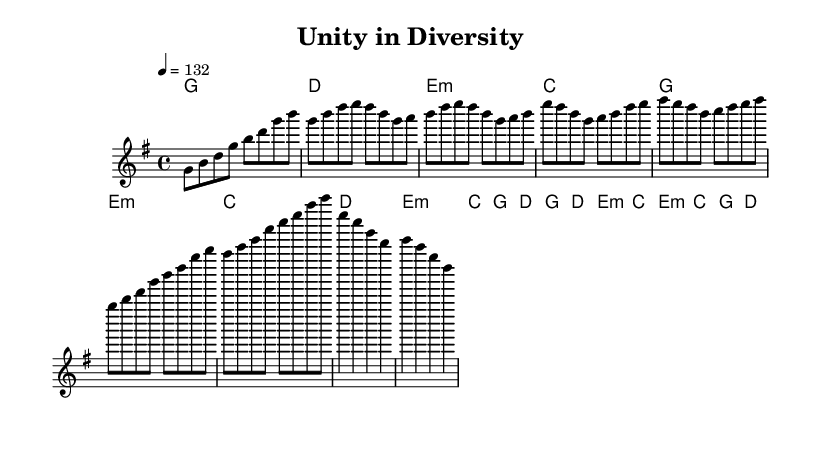What is the key signature of this music? The key signature is G major, which has one sharp (F#).
Answer: G major What is the time signature of this music? The time signature is 4/4, indicating four beats per measure.
Answer: 4/4 What is the tempo marking of this piece? The tempo marking is 132 beats per minute, as indicated by "4 = 132."
Answer: 132 How many measures are in the bridge section? The bridge section consists of two measures, as seen in the number of bars in that segment.
Answer: 2 What is the chord progression of the pre-chorus? The chord progression in the pre-chorus is E minor, C, G, D, based on the harmony dictated under that section.
Answer: E minor, C, G, D What section follows the verse in this song structure? The section that follows the verse is the pre-chorus, identifiable by its position after the verse in the score.
Answer: Pre-Chorus What is a unique feature of K-Pop reflected in this piece? A unique feature of K-Pop reflected in this piece is the combination of upbeat melodies and rich chord harmonies, which is common in the genre's celebration of diversity.
Answer: Upbeat melodies and rich chord harmonies 